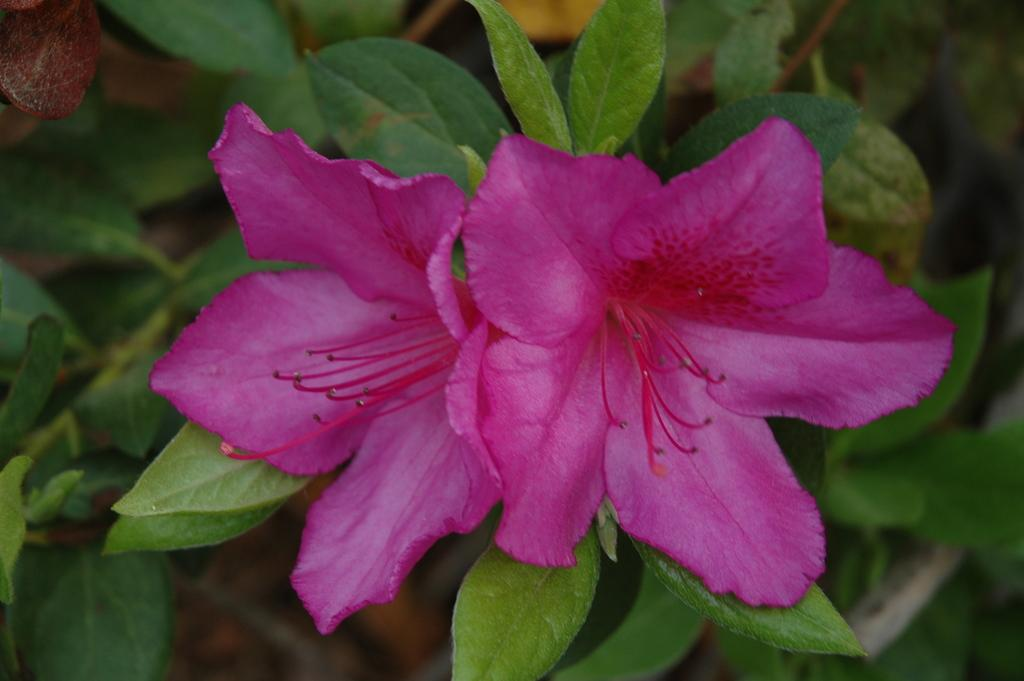What color are the flowers in the image? The flowers in the image are pink. What other color can be seen in the image besides pink? There are green color leaves in the image. Can you describe the background of the image? The background of the image is blurred. How many dolls are holding a hammer in the image? There are no dolls or hammers present in the image. 